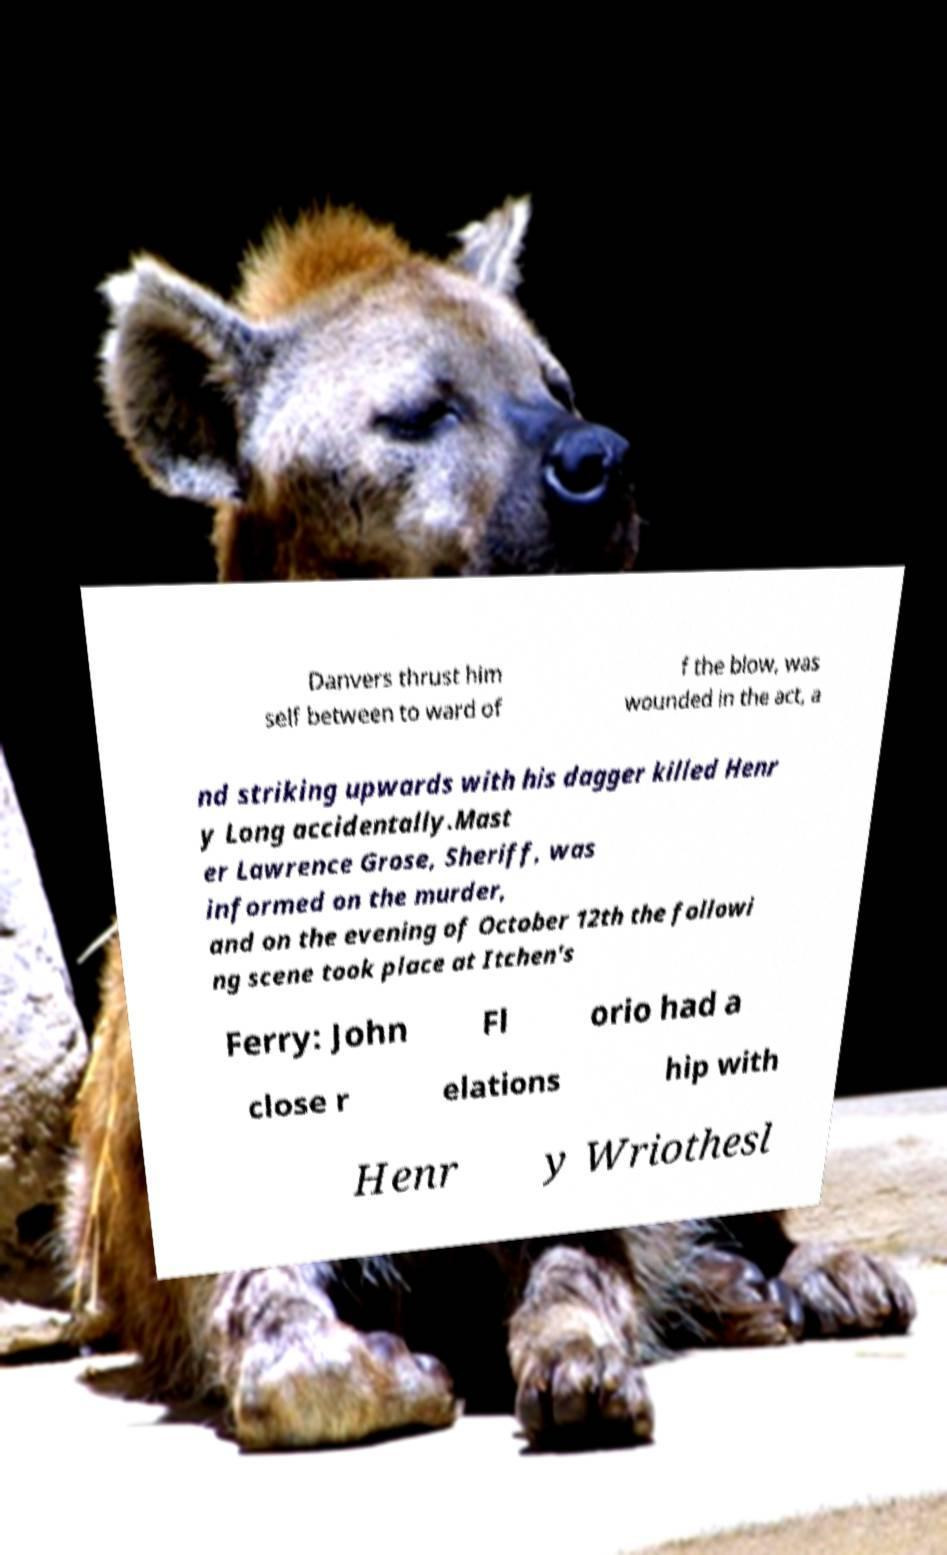I need the written content from this picture converted into text. Can you do that? Danvers thrust him self between to ward of f the blow, was wounded in the act, a nd striking upwards with his dagger killed Henr y Long accidentally.Mast er Lawrence Grose, Sheriff, was informed on the murder, and on the evening of October 12th the followi ng scene took place at Itchen's Ferry: John Fl orio had a close r elations hip with Henr y Wriothesl 